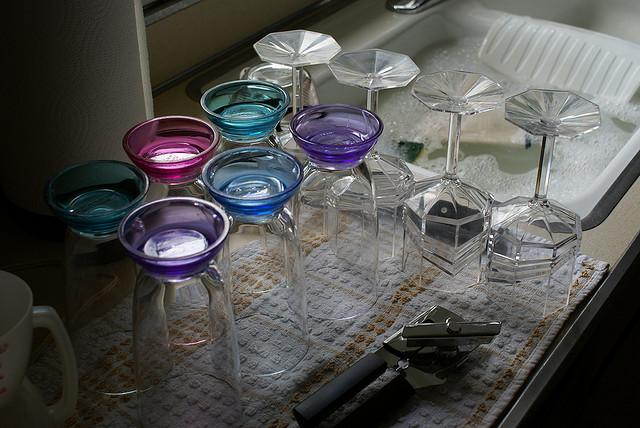Why are the glasses on a rag next to the sink? drying 